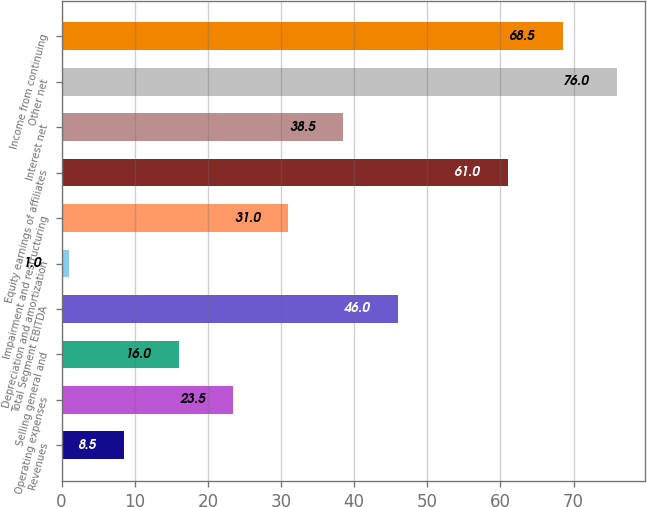<chart> <loc_0><loc_0><loc_500><loc_500><bar_chart><fcel>Revenues<fcel>Operating expenses<fcel>Selling general and<fcel>Total Segment EBITDA<fcel>Depreciation and amortization<fcel>Impairment and restructuring<fcel>Equity earnings of affiliates<fcel>Interest net<fcel>Other net<fcel>Income from continuing<nl><fcel>8.5<fcel>23.5<fcel>16<fcel>46<fcel>1<fcel>31<fcel>61<fcel>38.5<fcel>76<fcel>68.5<nl></chart> 